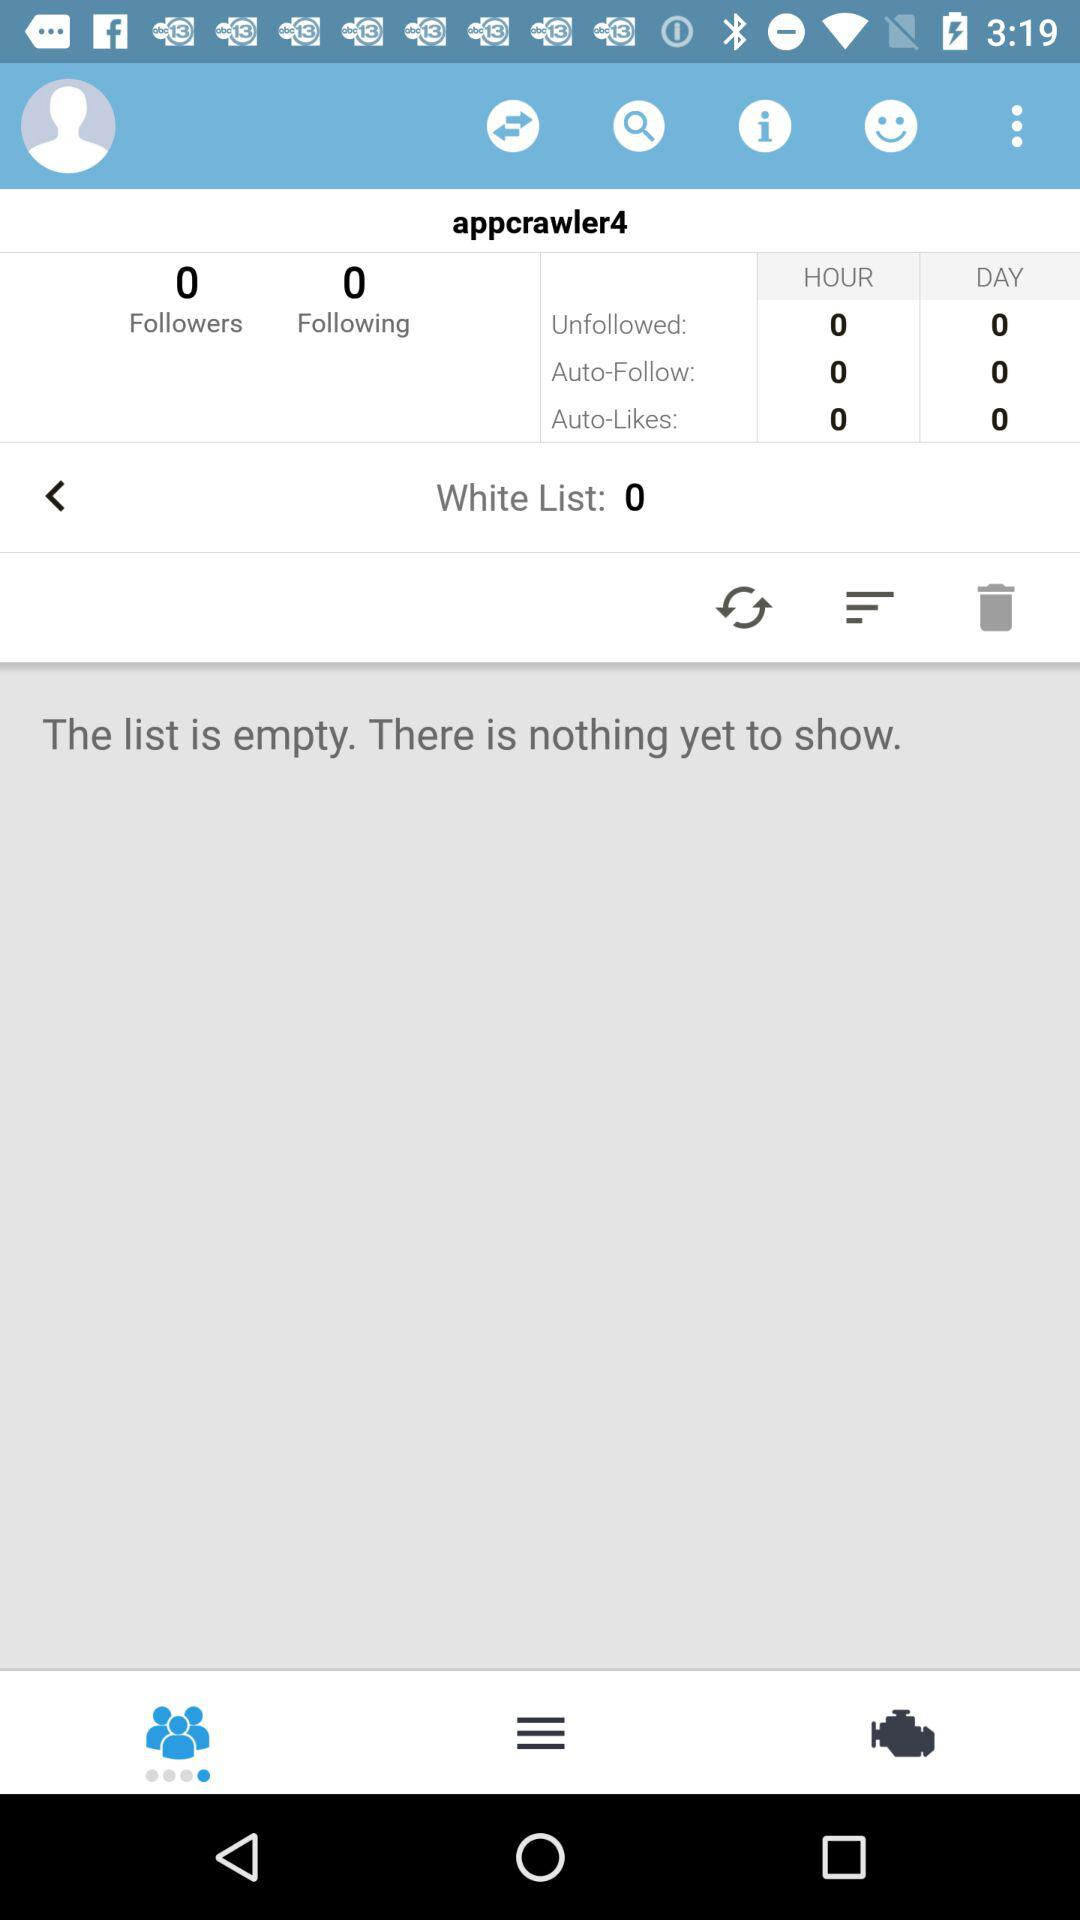What is the username? The username is "appcrawler4". 